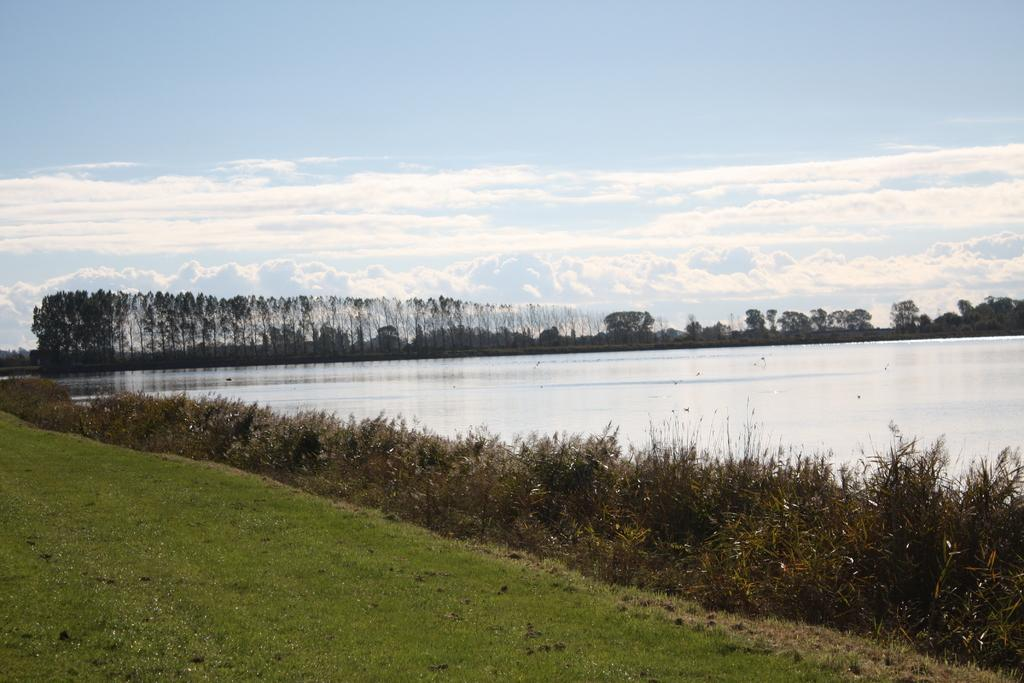What is visible in the image that covers the ground? There is grass on the ground in the image. What natural element is present in the image besides grass? There is water visible in the image. What can be seen in the background of the image? There are trees in the background of the image. What is visible at the top of the image? The sky is visible at the top of the image. What can be observed in the sky? Clouds are present in the sky. How many sheep are visible in the image? There are no sheep present in the image. What direction does the partner need to walk to reach the water in the image? There is no partner or indication of direction in the image. 